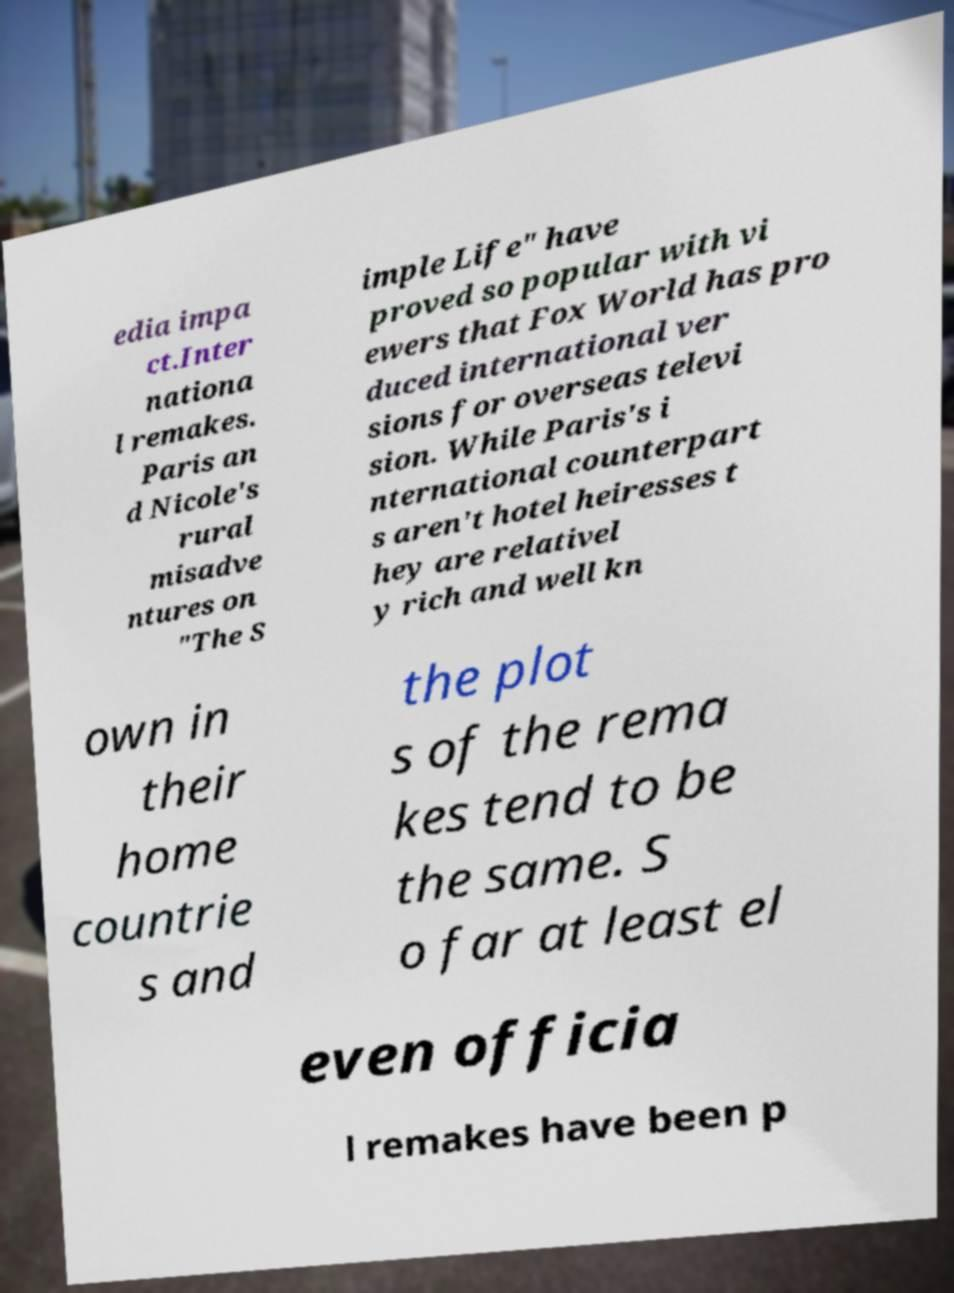Please identify and transcribe the text found in this image. edia impa ct.Inter nationa l remakes. Paris an d Nicole's rural misadve ntures on "The S imple Life" have proved so popular with vi ewers that Fox World has pro duced international ver sions for overseas televi sion. While Paris's i nternational counterpart s aren't hotel heiresses t hey are relativel y rich and well kn own in their home countrie s and the plot s of the rema kes tend to be the same. S o far at least el even officia l remakes have been p 